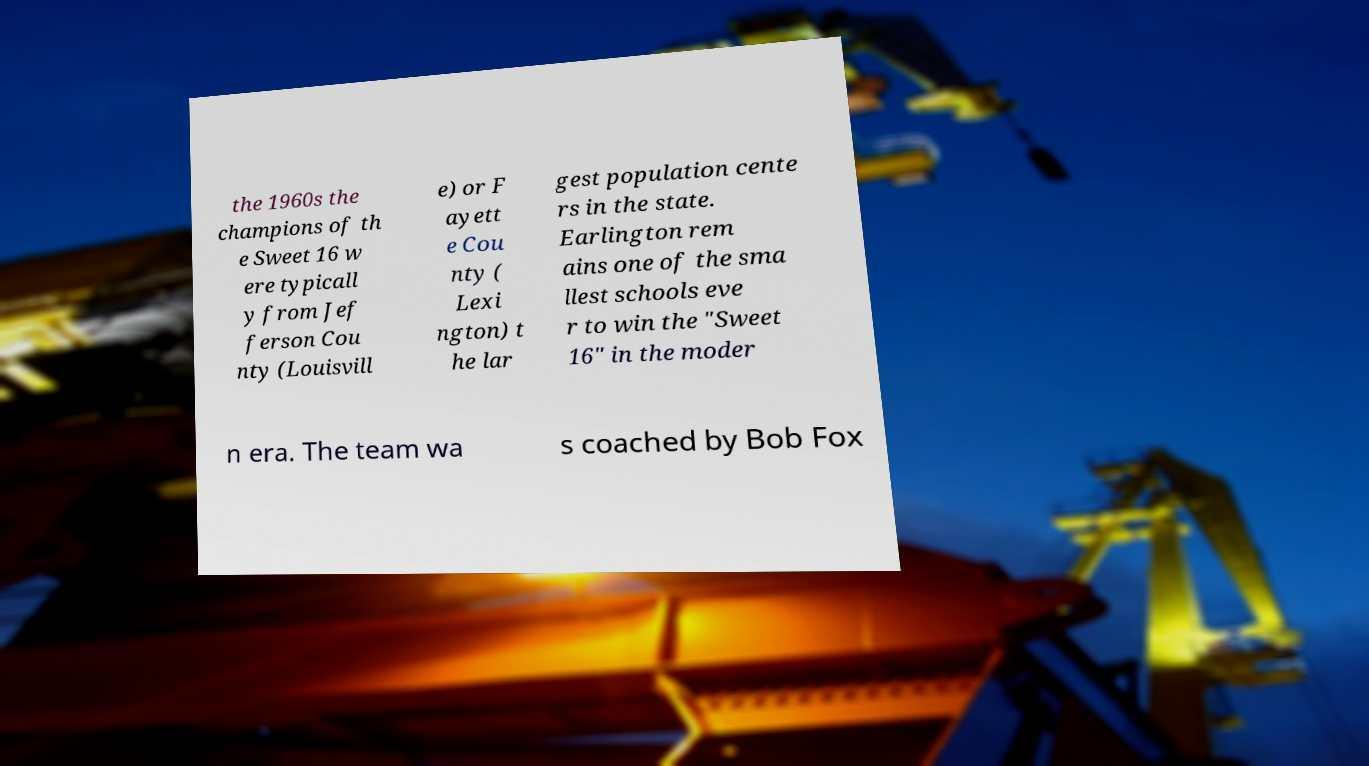Can you accurately transcribe the text from the provided image for me? the 1960s the champions of th e Sweet 16 w ere typicall y from Jef ferson Cou nty (Louisvill e) or F ayett e Cou nty ( Lexi ngton) t he lar gest population cente rs in the state. Earlington rem ains one of the sma llest schools eve r to win the "Sweet 16" in the moder n era. The team wa s coached by Bob Fox 